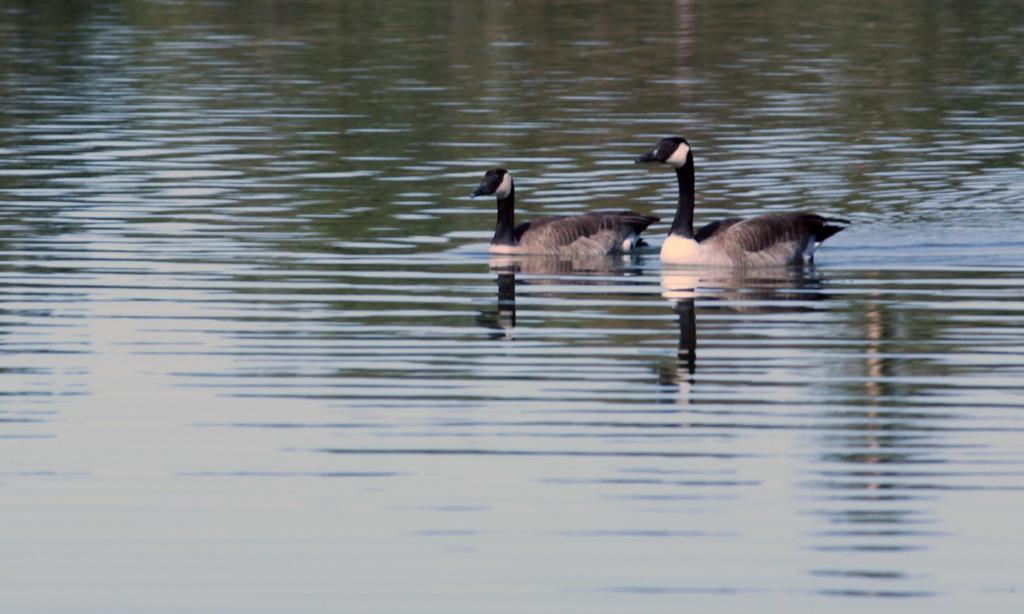Please provide a concise description of this image. In this image there are two ducks present on the water. 